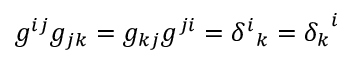<formula> <loc_0><loc_0><loc_500><loc_500>g ^ { i j } g _ { j k } = g _ { k j } g ^ { j i } = { \delta ^ { i } } _ { k } = { \delta _ { k } } ^ { i }</formula> 